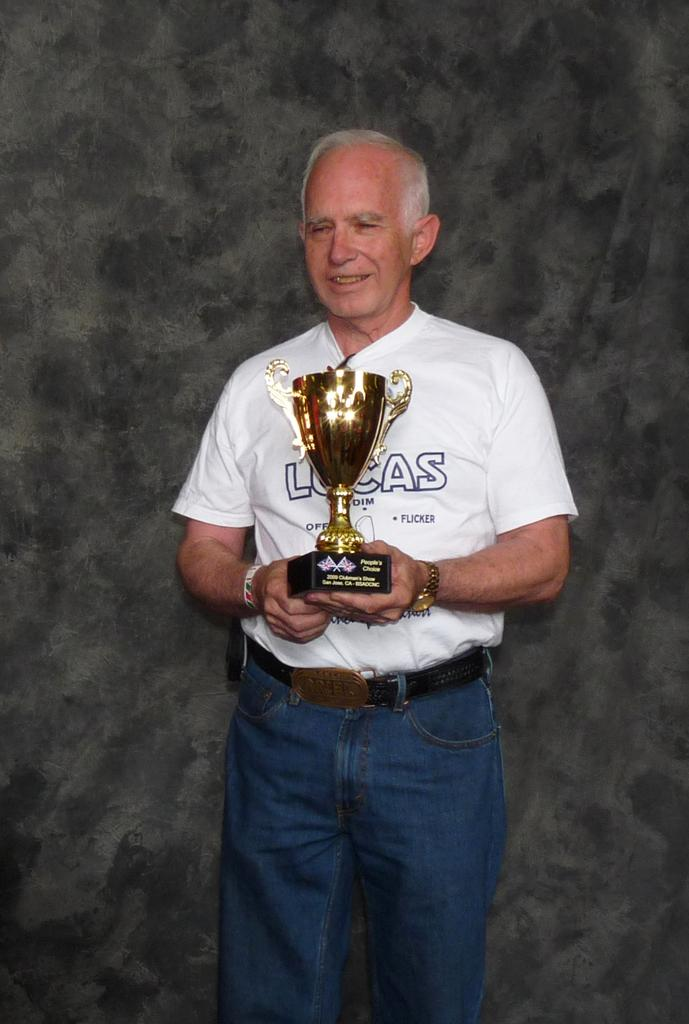What is the main subject of the picture? The main subject of the picture is a man. What is the man wearing? The man is wearing a white T-shirt and blue jeans. What is the man holding in his hands? The man is holding a trophy in his hands. What is the man's facial expression? The man is smiling. What colors are used in the background of the picture? The background is in grey and black color. Can you tell me how many pots are visible in the image? There are no pots present in the image. What type of current is flowing through the man's body in the image? There is no indication of any current flowing through the man's body in the image. 